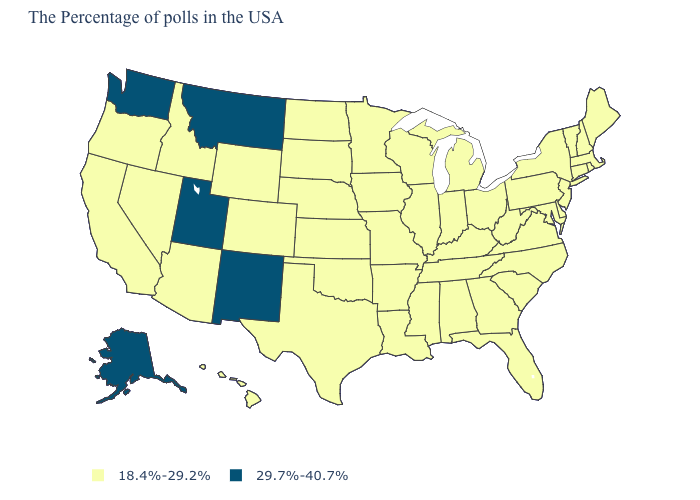What is the value of Kansas?
Be succinct. 18.4%-29.2%. How many symbols are there in the legend?
Quick response, please. 2. What is the value of South Carolina?
Concise answer only. 18.4%-29.2%. What is the highest value in the South ?
Write a very short answer. 18.4%-29.2%. What is the value of New York?
Write a very short answer. 18.4%-29.2%. Among the states that border Vermont , which have the highest value?
Keep it brief. Massachusetts, New Hampshire, New York. Does Washington have the lowest value in the USA?
Keep it brief. No. What is the lowest value in states that border California?
Short answer required. 18.4%-29.2%. What is the highest value in the USA?
Concise answer only. 29.7%-40.7%. Name the states that have a value in the range 29.7%-40.7%?
Short answer required. New Mexico, Utah, Montana, Washington, Alaska. Name the states that have a value in the range 29.7%-40.7%?
Short answer required. New Mexico, Utah, Montana, Washington, Alaska. What is the value of New York?
Be succinct. 18.4%-29.2%. Name the states that have a value in the range 29.7%-40.7%?
Be succinct. New Mexico, Utah, Montana, Washington, Alaska. 